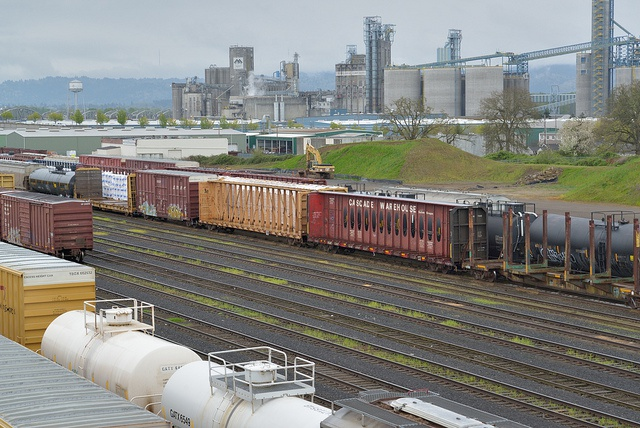Describe the objects in this image and their specific colors. I can see train in lightgray, darkgray, gray, and tan tones, train in lightgray, gray, black, brown, and maroon tones, train in lightgray, brown, maroon, gray, and black tones, and train in lightgray, brown, gray, darkgray, and maroon tones in this image. 